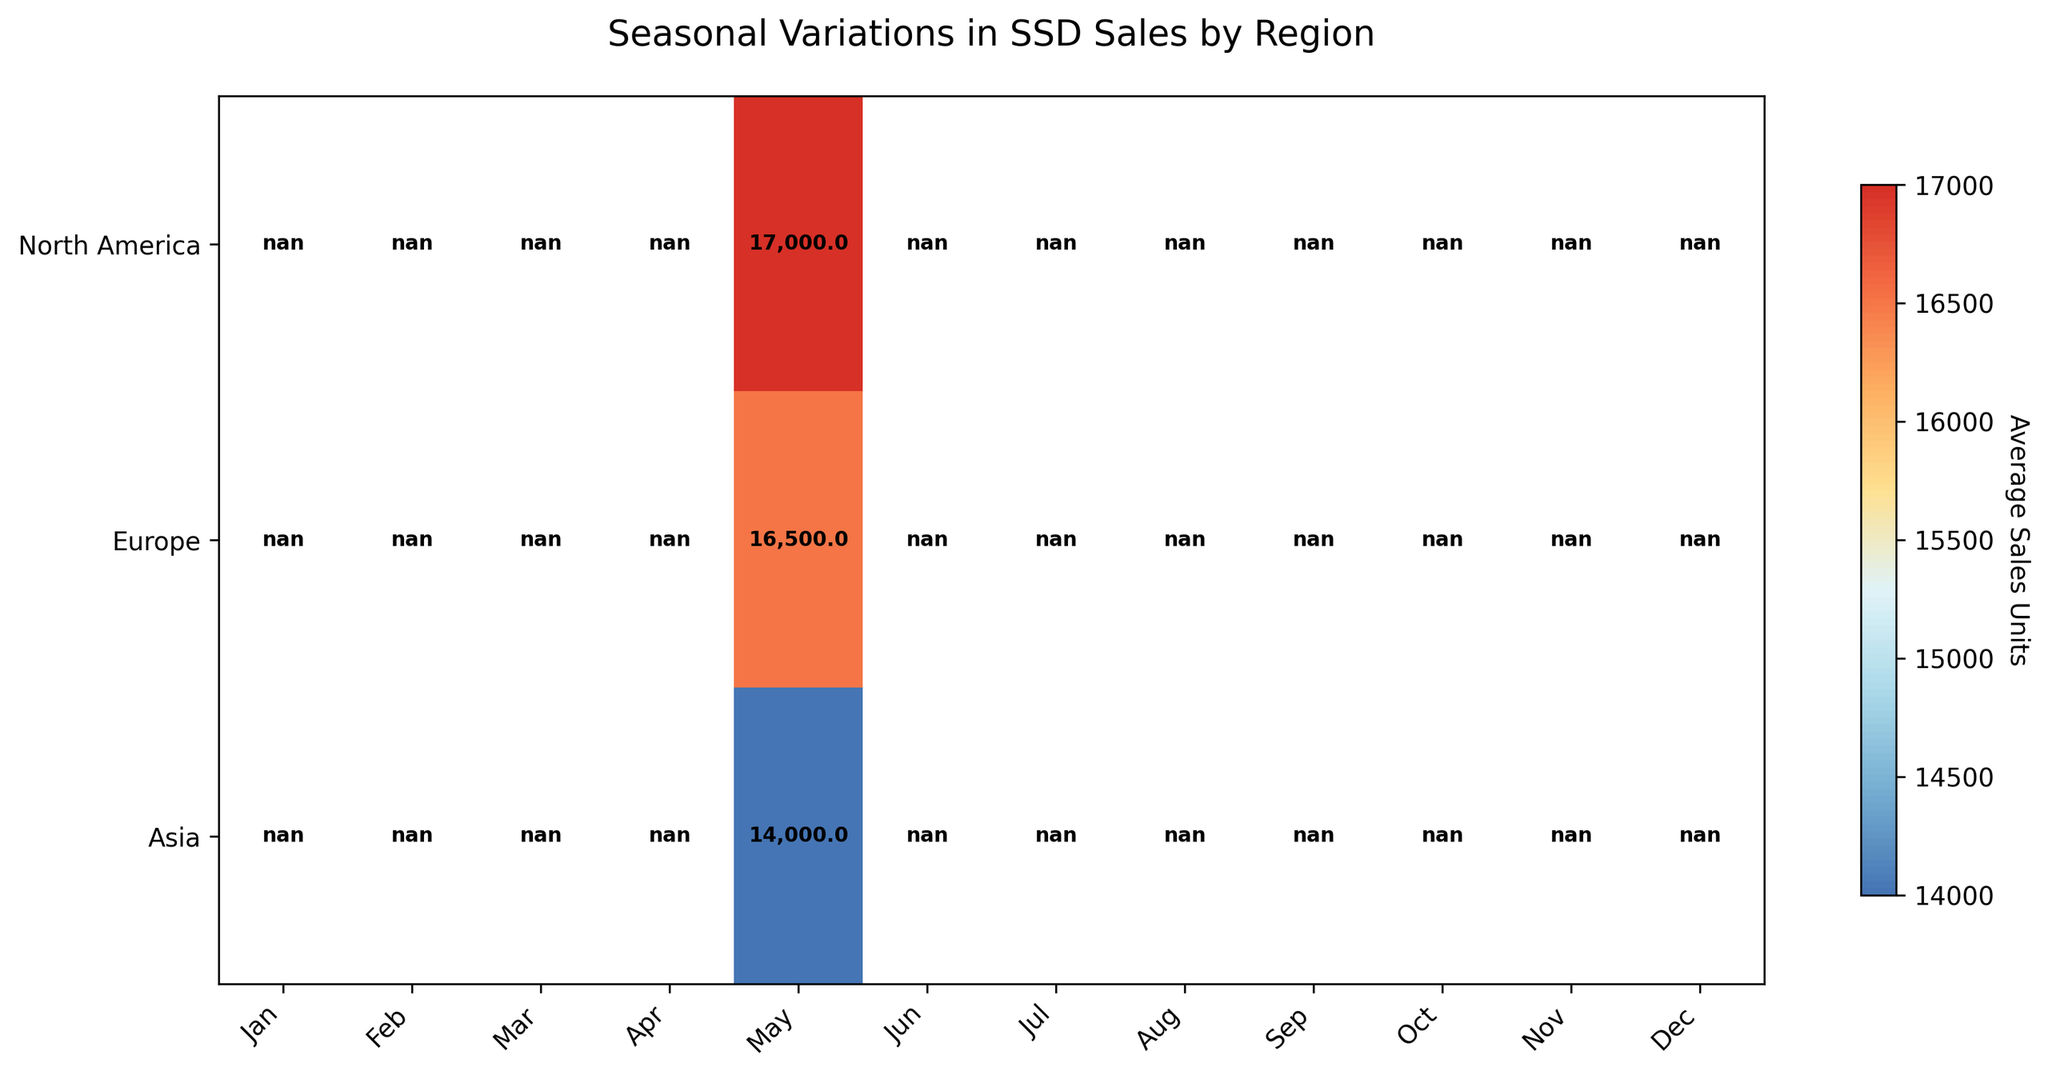What is the title of the plot? The title is located at the top center of the figure. It provides a summary of what the figure represents. In this case, it states "Seasonal Variations in SSD Sales by Region."
Answer: Seasonal Variations in SSD Sales by Region Which region reported the highest average SSD sales units in December? The December column shows the values across all regions. The figure for North America is 20,000, Europe is 18,000, and Asia is 16,000. North America has the highest value.
Answer: North America How do the sales in North America compare between January and December? Look at the rows corresponding to North America for January and December. The sales in January are 15,000 units and in December they are 20,000 units. December sales are higher by 5,000 units.
Answer: December sales are higher by 5,000 units Which month recorded the lowest average sales units in Asia? In the Asia row, scan through the values to find the lowest value. The lowest value is 10,000 units in January.
Answer: January By how much do November's SSD sales exceed October's in Europe? Examine the values in the Europe row for November (17,000 units) and October (15,500 units). Subtract October's sales from November’s: 17,000 - 15,500 = 1,500 units.
Answer: 1,500 units What is the average number of SSD sales units in North America for the first half of the year (January to June)? Add the sales units from January to June in North America (15,000 + 16,000 + 17,500 + 18,000 + 17,000 + 16,000 = 99,500) and divide by 6 (99,500 / 6).
Answer: 16,583 units Which region experienced the least fluctuation in SSD sales throughout the year? The Europe row has values that vary moderately between 13,000 and 18,000 units. For Asia, the range is 10,000 to 16,000. North America shows a range of 15,000 to 20,000. Europe has the least fluctuation.
Answer: Europe During which months did Europe surpass the 16,000 units sales mark? Check the Europe row and identify months with values above 16,000. Europe surpassed 16,000 units in May, November, and December.
Answer: May, November, December Comparing the sales units in May, which region has the highest figure? Review the values for May across all regions: North America (17,000), Europe (16,500), Asia (14,000). North America has the highest figure.
Answer: North America What is the combined average sales units in August across all regions? Add the values for August across all regions: North America (15,500), Europe (14,500), Asia (12,500). The total is 15,500 + 14,500 + 12,500 = 42,500. Divide by 3 to get the average: 42,500 / 3 = 14,167.
Answer: 14,167 units 